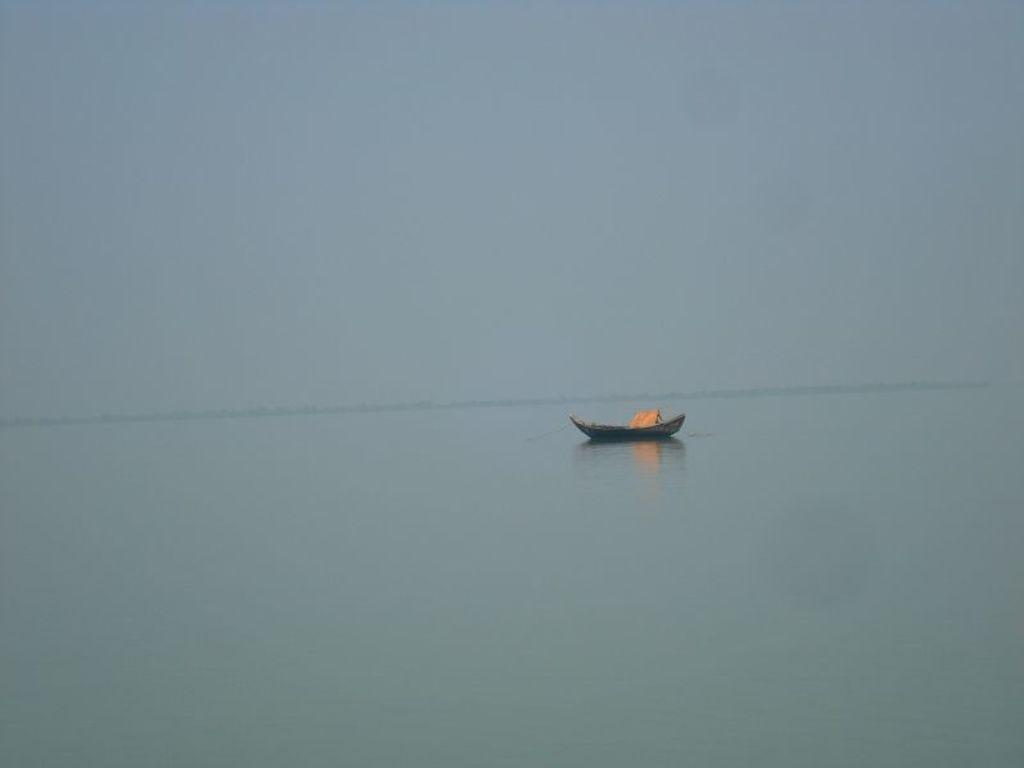What type of natural water feature is present in the image? There is a river in the image. What is on the river in the image? There is a boat on the river. What part of the natural environment is visible in the image? The sky is visible in the background of the image. What type of peace can be seen being made between the wax and the guide in the image? There is no reference to peace, wax, or a guide in the image; it features a river with a boat on it and a visible sky. 